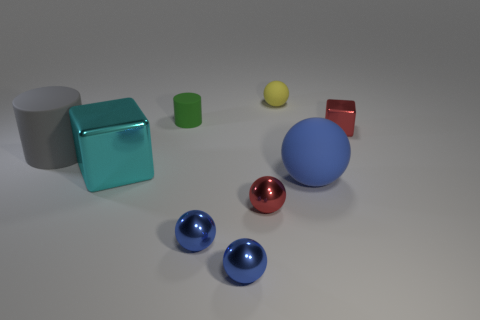Subtract all purple cubes. How many blue spheres are left? 3 Subtract all red spheres. How many spheres are left? 4 Subtract 2 spheres. How many spheres are left? 3 Subtract all tiny rubber spheres. How many spheres are left? 4 Subtract all green spheres. Subtract all gray blocks. How many spheres are left? 5 Add 1 tiny cylinders. How many objects exist? 10 Subtract all cylinders. How many objects are left? 7 Add 9 tiny yellow rubber spheres. How many tiny yellow rubber spheres exist? 10 Subtract 0 brown spheres. How many objects are left? 9 Subtract all large blue rubber balls. Subtract all tiny metal objects. How many objects are left? 4 